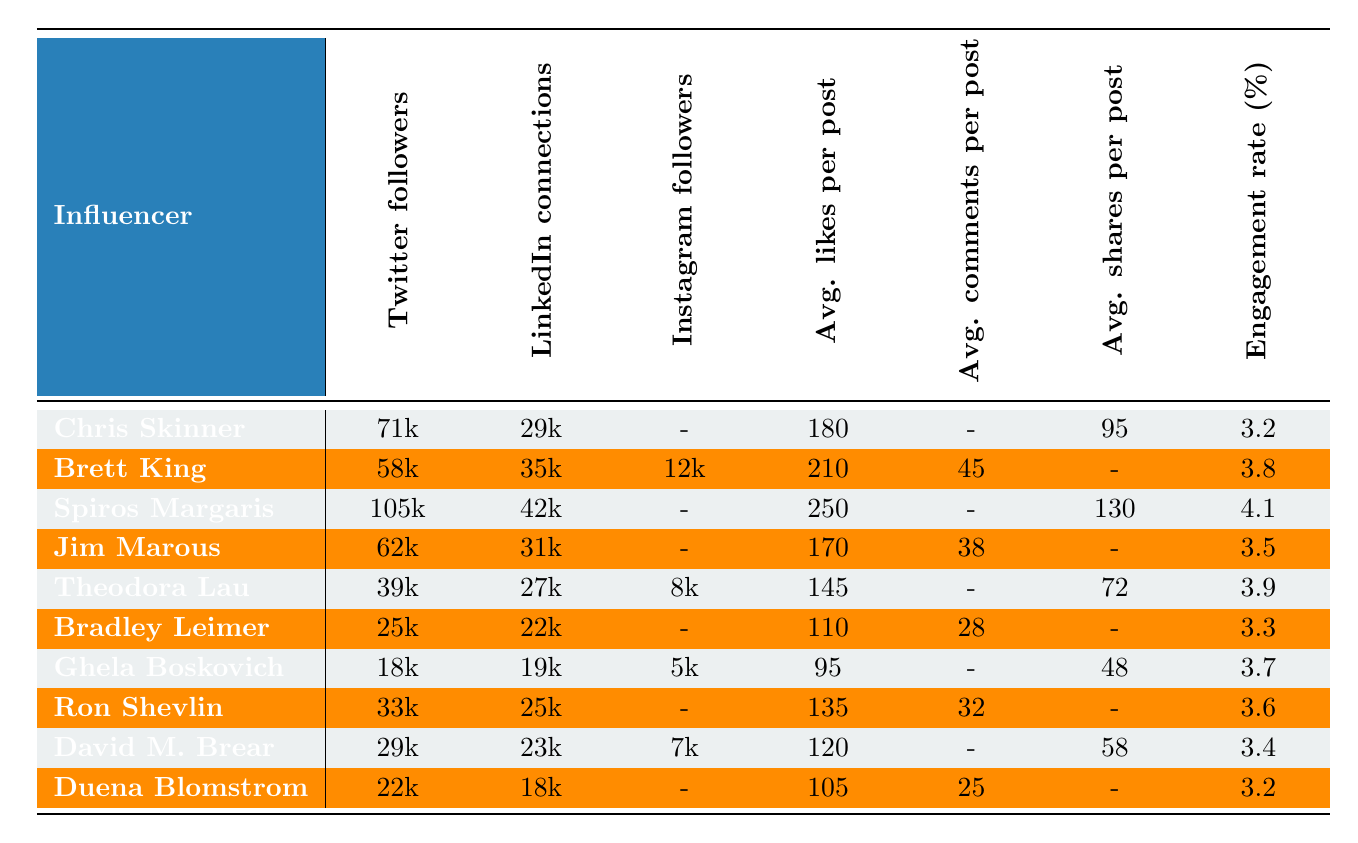What is the highest engagement rate among the influencers listed? By scanning the engagement rates, Spiros Margaris has the highest engagement rate at 4.1%.
Answer: 4.1% Which influencer has the most Twitter followers? Spiros Margaris has the highest number of Twitter followers at 105,000.
Answer: 105,000 How many influencers have Instagram followers listed? Four influencers have Instagram followers listed: Brett King, Theodora Lau, Ghela Boskovich, and David M. Brear.
Answer: Four What is the total number of LinkedIn connections among all influencers? Adding the LinkedIn connections together gives: 29000 + 35000 + 42000 + 31000 + 27000 + 22000 + 19000 + 25000 + 23000 + 18000 = 229,000.
Answer: 229,000 Is there an influencer with more average likes per post than their Instagram followers? Yes, Brett King has 210 average likes per post and 12,000 Instagram followers, which is higher than the number of Instagram followers.
Answer: Yes Which influencer has the lowest average likes per post? Bradley Leimer has the lowest average likes per post at 110.
Answer: 110 What is the average engagement rate of all influencers listed? To find the average engagement rate: (3.2 + 3.8 + 4.1 + 3.5 + 3.9 + 3.3 + 3.7 + 3.6 + 3.4 + 3.2) / 10 = 3.56%.
Answer: 3.56% How many more LinkedIn connections does Spiros Margaris have compared to Chris Skinner? Spiros Margaris has 42,000 LinkedIn connections while Chris Skinner has 29,000; the difference is 42,000 - 29,000 = 13,000.
Answer: 13,000 Which influencer has the least overall social media presence (considering Twitter followers + LinkedIn connections + Instagram followers)? Ghela Boskovich has 18,000 Twitter followers, 19,000 LinkedIn connections, and 5,000 Instagram followers; total = 18,000 + 19,000 + 5,000 = 42,000. There are no celebrities with a less total count.
Answer: Ghela Boskovich How does Jim Marous' engagement rate compare to that of David M. Brear? Jim Marous has an engagement rate of 3.5%, while David M. Brear has 3.4%. Jim Marous has a higher engagement rate than David M. Brear.
Answer: Yes 